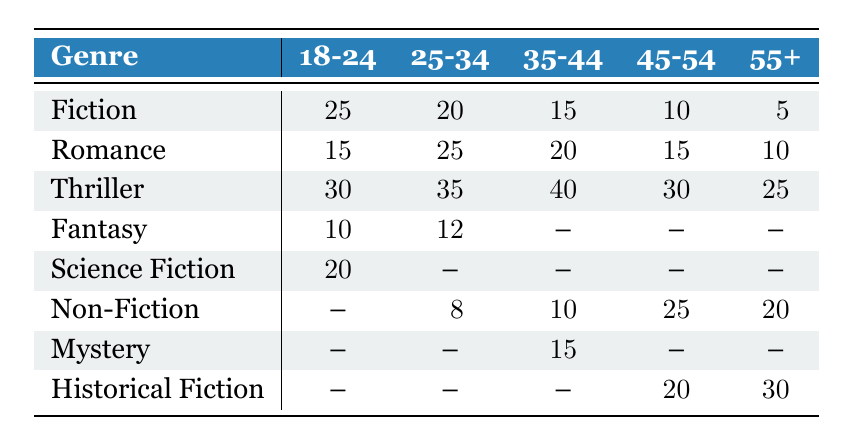What is the most popular genre among the 35-44 age group? The most popular genre for the 35-44 age group can be identified by looking at the values in that row. The Thriller genre has the highest value of 40, which is greater than the values of other genres in that row.
Answer: Thriller Which age group shows the highest interest in Romance? By examining the Romance row, we see that the 25-34 age group has the highest value at 25, compared to the other age groups. Thus, they show the most interest in the Romance genre.
Answer: 25-34 What is the sum of Fiction and Non-Fiction readers in the 45-54 age group? We add the number of readers for Fiction (10) and Non-Fiction (25) for the 45-54 age group. So, the sum is 10 + 25 = 35.
Answer: 35 Is there a genre that all age groups enjoy equally? Looking at the table, we see that there are no genres that have values in every age group. Some genres, like Fantasy and Science Fiction, are absent in older age groups, indicating no genre is enjoyed equally.
Answer: No What is the difference in Thriller readers between the 25-34 and 55+ age groups? We first find the number of Thriller readers in both age groups: 25-34 has 35 readers and 55+ has 25 readers. The difference is 35 - 25 = 10.
Answer: 10 Which genre has the least number of readers in the 18-24 age group? In the 18-24 age group, we can compare the values of each genre. Fiction has 25, Romance has 15, Thriller has 30, Fantasy has 10, and Science Fiction has 20. The least number of readers is for Fantasy with 10.
Answer: Fantasy What is the average number of Thriller readers across all age groups? We sum the Thriller readers across all age groups: 30 (18-24) + 35 (25-34) + 40 (35-44) + 30 (45-54) + 25 (55+) = 160. Then, we divide by the number of age groups, which is 5. So, the average is 160 / 5 = 32.
Answer: 32 Is Historical Fiction a popular genre among younger age groups? By checking the data, Historical Fiction is only present in the 45-54 and 55+ age groups, as there are no values for younger age groups. Therefore, it is not popular among the younger readers.
Answer: No How many genres have a higher readership in the 25-34 age group compared to the 45-54 age group? We compare every genre's readership in both age groups: Fiction (20 vs 10), Romance (25 vs 15), Thriller (35 vs 30), Fantasy (12 vs -), Science Fiction (- vs -), Non-Fiction (8 vs 25). The genres that have higher readership in the 25-34 age group are Fiction, Romance, and Thriller. That totals three genres.
Answer: 3 